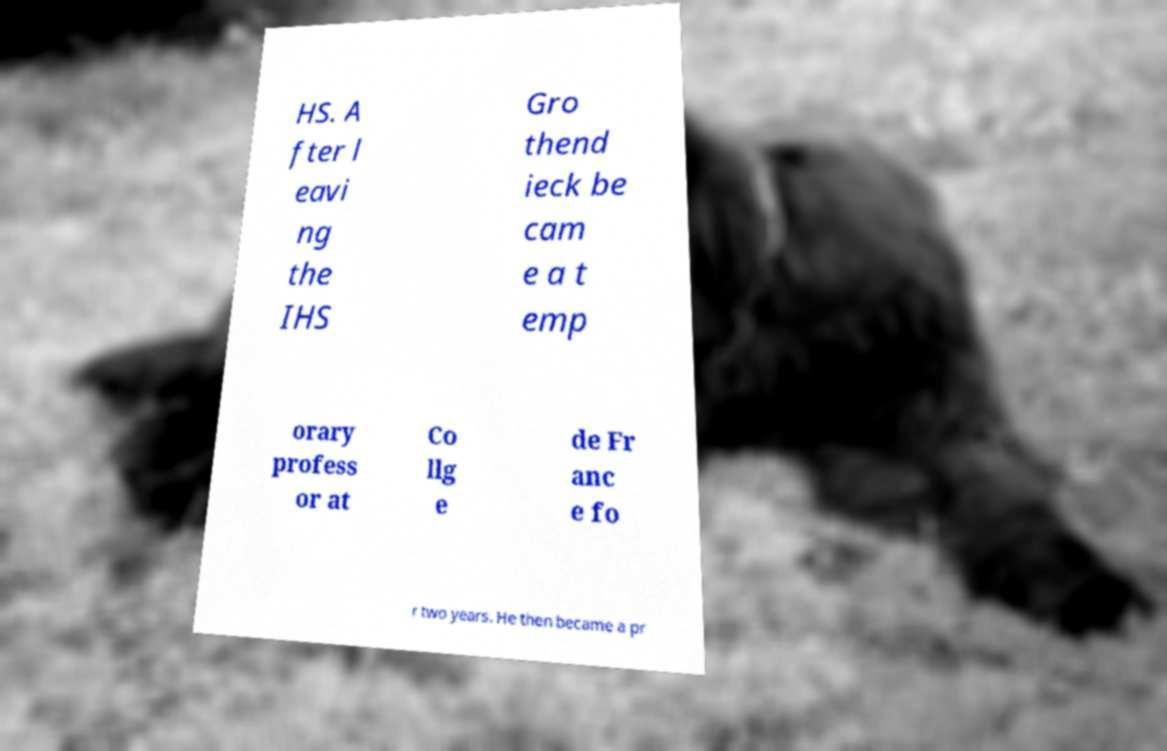Please read and relay the text visible in this image. What does it say? HS. A fter l eavi ng the IHS Gro thend ieck be cam e a t emp orary profess or at Co llg e de Fr anc e fo r two years. He then became a pr 